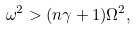Convert formula to latex. <formula><loc_0><loc_0><loc_500><loc_500>\omega ^ { 2 } > ( n \gamma + 1 ) \Omega ^ { 2 } ,</formula> 